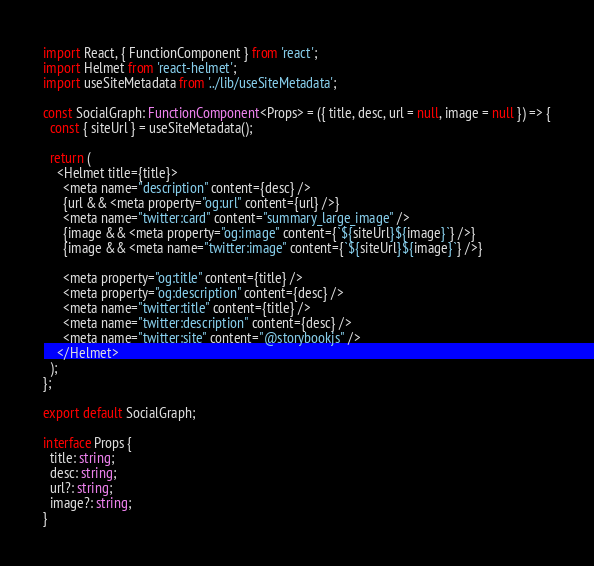<code> <loc_0><loc_0><loc_500><loc_500><_TypeScript_>import React, { FunctionComponent } from 'react';
import Helmet from 'react-helmet';
import useSiteMetadata from '../lib/useSiteMetadata';

const SocialGraph: FunctionComponent<Props> = ({ title, desc, url = null, image = null }) => {
  const { siteUrl } = useSiteMetadata();

  return (
    <Helmet title={title}>
      <meta name="description" content={desc} />
      {url && <meta property="og:url" content={url} />}
      <meta name="twitter:card" content="summary_large_image" />
      {image && <meta property="og:image" content={`${siteUrl}${image}`} />}
      {image && <meta name="twitter:image" content={`${siteUrl}${image}`} />}

      <meta property="og:title" content={title} />
      <meta property="og:description" content={desc} />
      <meta name="twitter:title" content={title} />
      <meta name="twitter:description" content={desc} />
      <meta name="twitter:site" content="@storybookjs" />
    </Helmet>
  );
};

export default SocialGraph;

interface Props {
  title: string;
  desc: string;
  url?: string;
  image?: string;
}
</code> 